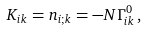<formula> <loc_0><loc_0><loc_500><loc_500>K _ { i k } = n _ { i ; k } = - N \Gamma ^ { 0 } _ { i k } \, ,</formula> 